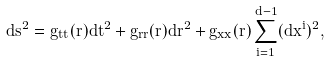<formula> <loc_0><loc_0><loc_500><loc_500>d s ^ { 2 } = g _ { t t } ( r ) d t ^ { 2 } + g _ { r r } ( r ) d r ^ { 2 } + g _ { x x } ( r ) \sum _ { i = 1 } ^ { d - 1 } ( d x ^ { i } ) ^ { 2 } ,</formula> 